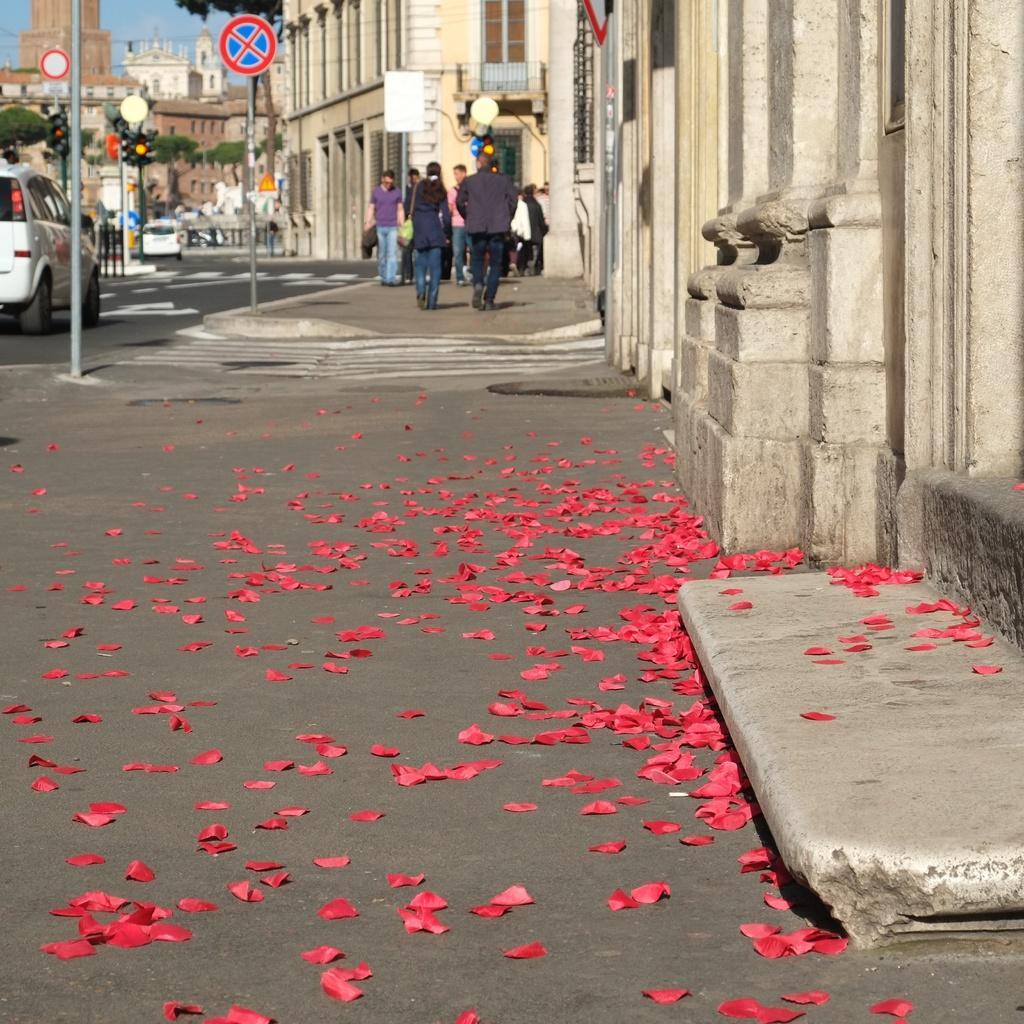Describe this image in one or two sentences. In this image I can see group of people, some are standing and some are walking and I can see few vehicles, traffic signals, few poles, buildings and the sky is in blue color. 